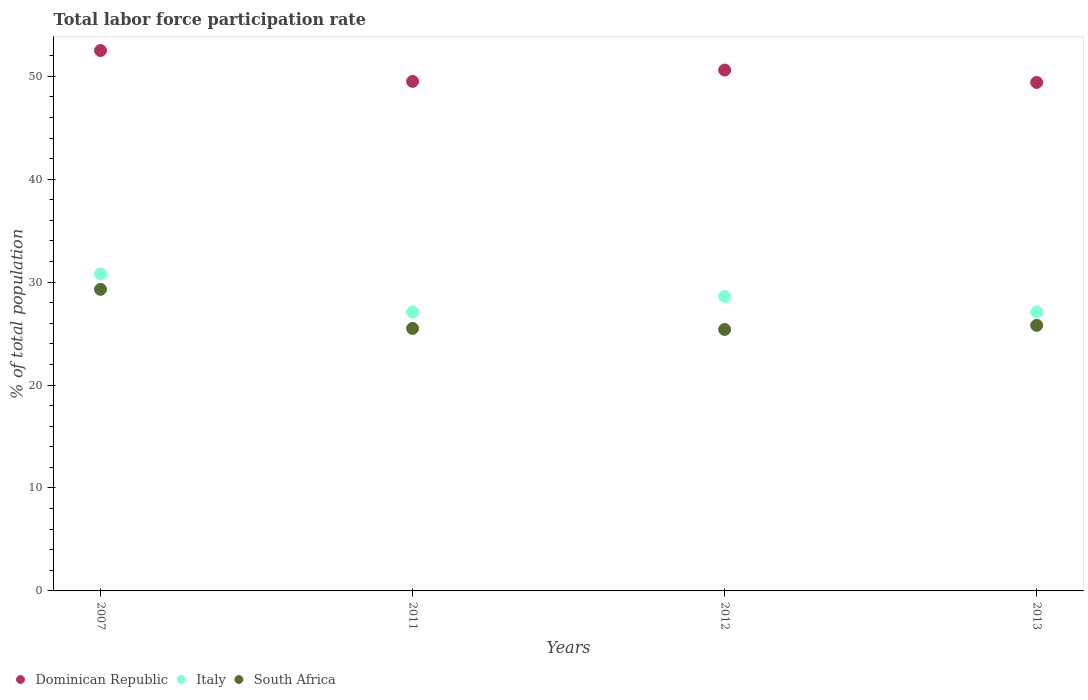How many different coloured dotlines are there?
Provide a short and direct response. 3. What is the total labor force participation rate in South Africa in 2012?
Provide a succinct answer. 25.4. Across all years, what is the maximum total labor force participation rate in Dominican Republic?
Make the answer very short. 52.5. Across all years, what is the minimum total labor force participation rate in Italy?
Offer a terse response. 27.1. In which year was the total labor force participation rate in Dominican Republic maximum?
Make the answer very short. 2007. What is the total total labor force participation rate in Italy in the graph?
Ensure brevity in your answer.  113.6. What is the difference between the total labor force participation rate in Dominican Republic in 2011 and that in 2012?
Ensure brevity in your answer.  -1.1. What is the difference between the total labor force participation rate in South Africa in 2011 and the total labor force participation rate in Dominican Republic in 2012?
Make the answer very short. -25.1. What is the average total labor force participation rate in Dominican Republic per year?
Give a very brief answer. 50.5. In the year 2011, what is the difference between the total labor force participation rate in Dominican Republic and total labor force participation rate in Italy?
Provide a succinct answer. 22.4. What is the ratio of the total labor force participation rate in Dominican Republic in 2007 to that in 2011?
Your answer should be very brief. 1.06. Is the total labor force participation rate in Italy in 2007 less than that in 2012?
Keep it short and to the point. No. What is the difference between the highest and the second highest total labor force participation rate in Italy?
Provide a succinct answer. 2.2. What is the difference between the highest and the lowest total labor force participation rate in South Africa?
Keep it short and to the point. 3.9. In how many years, is the total labor force participation rate in Italy greater than the average total labor force participation rate in Italy taken over all years?
Offer a terse response. 2. Is the sum of the total labor force participation rate in Italy in 2011 and 2013 greater than the maximum total labor force participation rate in Dominican Republic across all years?
Provide a short and direct response. Yes. Is it the case that in every year, the sum of the total labor force participation rate in South Africa and total labor force participation rate in Dominican Republic  is greater than the total labor force participation rate in Italy?
Provide a short and direct response. Yes. Does the total labor force participation rate in Italy monotonically increase over the years?
Your response must be concise. No. Does the graph contain any zero values?
Offer a terse response. No. Where does the legend appear in the graph?
Your response must be concise. Bottom left. How are the legend labels stacked?
Ensure brevity in your answer.  Horizontal. What is the title of the graph?
Offer a very short reply. Total labor force participation rate. What is the label or title of the X-axis?
Provide a succinct answer. Years. What is the label or title of the Y-axis?
Your response must be concise. % of total population. What is the % of total population of Dominican Republic in 2007?
Your answer should be very brief. 52.5. What is the % of total population of Italy in 2007?
Ensure brevity in your answer.  30.8. What is the % of total population of South Africa in 2007?
Your response must be concise. 29.3. What is the % of total population in Dominican Republic in 2011?
Your response must be concise. 49.5. What is the % of total population in Italy in 2011?
Give a very brief answer. 27.1. What is the % of total population in South Africa in 2011?
Your response must be concise. 25.5. What is the % of total population in Dominican Republic in 2012?
Ensure brevity in your answer.  50.6. What is the % of total population in Italy in 2012?
Give a very brief answer. 28.6. What is the % of total population in South Africa in 2012?
Provide a succinct answer. 25.4. What is the % of total population of Dominican Republic in 2013?
Ensure brevity in your answer.  49.4. What is the % of total population of Italy in 2013?
Your answer should be very brief. 27.1. What is the % of total population in South Africa in 2013?
Keep it short and to the point. 25.8. Across all years, what is the maximum % of total population in Dominican Republic?
Provide a short and direct response. 52.5. Across all years, what is the maximum % of total population of Italy?
Keep it short and to the point. 30.8. Across all years, what is the maximum % of total population in South Africa?
Make the answer very short. 29.3. Across all years, what is the minimum % of total population of Dominican Republic?
Ensure brevity in your answer.  49.4. Across all years, what is the minimum % of total population of Italy?
Offer a terse response. 27.1. Across all years, what is the minimum % of total population in South Africa?
Your answer should be compact. 25.4. What is the total % of total population of Dominican Republic in the graph?
Provide a short and direct response. 202. What is the total % of total population in Italy in the graph?
Give a very brief answer. 113.6. What is the total % of total population in South Africa in the graph?
Keep it short and to the point. 106. What is the difference between the % of total population of Italy in 2007 and that in 2011?
Your answer should be very brief. 3.7. What is the difference between the % of total population of Dominican Republic in 2007 and that in 2012?
Give a very brief answer. 1.9. What is the difference between the % of total population of Dominican Republic in 2007 and that in 2013?
Ensure brevity in your answer.  3.1. What is the difference between the % of total population of Italy in 2007 and that in 2013?
Provide a short and direct response. 3.7. What is the difference between the % of total population of Dominican Republic in 2011 and that in 2012?
Keep it short and to the point. -1.1. What is the difference between the % of total population in Italy in 2011 and that in 2012?
Your answer should be compact. -1.5. What is the difference between the % of total population in Dominican Republic in 2011 and that in 2013?
Your response must be concise. 0.1. What is the difference between the % of total population of Italy in 2011 and that in 2013?
Keep it short and to the point. 0. What is the difference between the % of total population in South Africa in 2012 and that in 2013?
Keep it short and to the point. -0.4. What is the difference between the % of total population of Dominican Republic in 2007 and the % of total population of Italy in 2011?
Offer a very short reply. 25.4. What is the difference between the % of total population in Italy in 2007 and the % of total population in South Africa in 2011?
Keep it short and to the point. 5.3. What is the difference between the % of total population in Dominican Republic in 2007 and the % of total population in Italy in 2012?
Your answer should be very brief. 23.9. What is the difference between the % of total population in Dominican Republic in 2007 and the % of total population in South Africa in 2012?
Ensure brevity in your answer.  27.1. What is the difference between the % of total population in Italy in 2007 and the % of total population in South Africa in 2012?
Provide a succinct answer. 5.4. What is the difference between the % of total population in Dominican Republic in 2007 and the % of total population in Italy in 2013?
Offer a very short reply. 25.4. What is the difference between the % of total population in Dominican Republic in 2007 and the % of total population in South Africa in 2013?
Offer a terse response. 26.7. What is the difference between the % of total population in Dominican Republic in 2011 and the % of total population in Italy in 2012?
Provide a short and direct response. 20.9. What is the difference between the % of total population in Dominican Republic in 2011 and the % of total population in South Africa in 2012?
Provide a succinct answer. 24.1. What is the difference between the % of total population of Dominican Republic in 2011 and the % of total population of Italy in 2013?
Provide a succinct answer. 22.4. What is the difference between the % of total population of Dominican Republic in 2011 and the % of total population of South Africa in 2013?
Keep it short and to the point. 23.7. What is the difference between the % of total population of Dominican Republic in 2012 and the % of total population of South Africa in 2013?
Your answer should be very brief. 24.8. What is the average % of total population in Dominican Republic per year?
Keep it short and to the point. 50.5. What is the average % of total population of Italy per year?
Your response must be concise. 28.4. What is the average % of total population of South Africa per year?
Ensure brevity in your answer.  26.5. In the year 2007, what is the difference between the % of total population in Dominican Republic and % of total population in Italy?
Offer a terse response. 21.7. In the year 2007, what is the difference between the % of total population of Dominican Republic and % of total population of South Africa?
Offer a very short reply. 23.2. In the year 2007, what is the difference between the % of total population in Italy and % of total population in South Africa?
Your response must be concise. 1.5. In the year 2011, what is the difference between the % of total population of Dominican Republic and % of total population of Italy?
Your answer should be very brief. 22.4. In the year 2011, what is the difference between the % of total population of Dominican Republic and % of total population of South Africa?
Your answer should be very brief. 24. In the year 2012, what is the difference between the % of total population in Dominican Republic and % of total population in South Africa?
Make the answer very short. 25.2. In the year 2013, what is the difference between the % of total population in Dominican Republic and % of total population in Italy?
Offer a very short reply. 22.3. In the year 2013, what is the difference between the % of total population in Dominican Republic and % of total population in South Africa?
Make the answer very short. 23.6. What is the ratio of the % of total population of Dominican Republic in 2007 to that in 2011?
Make the answer very short. 1.06. What is the ratio of the % of total population in Italy in 2007 to that in 2011?
Make the answer very short. 1.14. What is the ratio of the % of total population of South Africa in 2007 to that in 2011?
Offer a terse response. 1.15. What is the ratio of the % of total population in Dominican Republic in 2007 to that in 2012?
Provide a short and direct response. 1.04. What is the ratio of the % of total population of South Africa in 2007 to that in 2012?
Provide a succinct answer. 1.15. What is the ratio of the % of total population in Dominican Republic in 2007 to that in 2013?
Provide a succinct answer. 1.06. What is the ratio of the % of total population in Italy in 2007 to that in 2013?
Your answer should be compact. 1.14. What is the ratio of the % of total population in South Africa in 2007 to that in 2013?
Give a very brief answer. 1.14. What is the ratio of the % of total population of Dominican Republic in 2011 to that in 2012?
Your response must be concise. 0.98. What is the ratio of the % of total population of Italy in 2011 to that in 2012?
Provide a succinct answer. 0.95. What is the ratio of the % of total population of South Africa in 2011 to that in 2012?
Provide a succinct answer. 1. What is the ratio of the % of total population in South Africa in 2011 to that in 2013?
Your answer should be compact. 0.99. What is the ratio of the % of total population of Dominican Republic in 2012 to that in 2013?
Ensure brevity in your answer.  1.02. What is the ratio of the % of total population of Italy in 2012 to that in 2013?
Make the answer very short. 1.06. What is the ratio of the % of total population of South Africa in 2012 to that in 2013?
Keep it short and to the point. 0.98. What is the difference between the highest and the second highest % of total population in Italy?
Your response must be concise. 2.2. What is the difference between the highest and the second highest % of total population of South Africa?
Your response must be concise. 3.5. What is the difference between the highest and the lowest % of total population of Italy?
Provide a short and direct response. 3.7. What is the difference between the highest and the lowest % of total population in South Africa?
Ensure brevity in your answer.  3.9. 